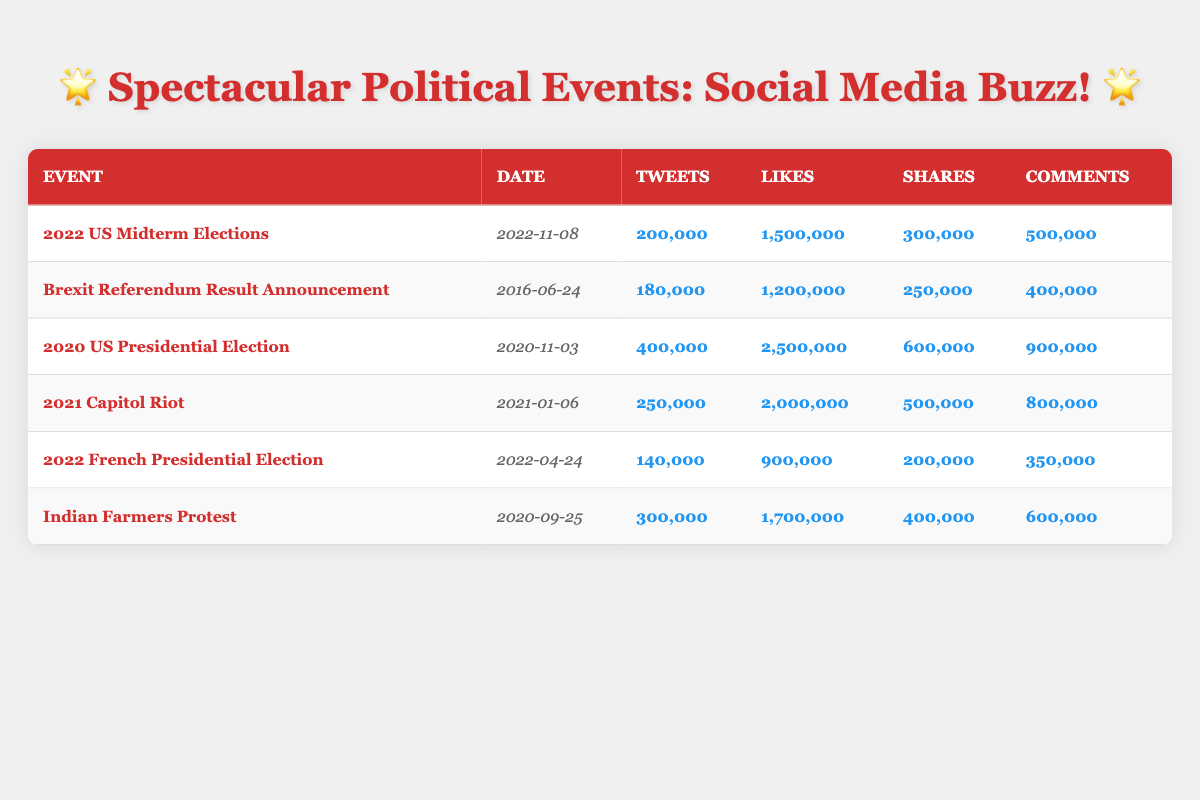What was the highest number of tweets recorded for a single event? The highest number of tweets among the events is found in the row for the 2020 US Presidential Election, which has 400,000 tweets.
Answer: 400,000 How many likes did the 2021 Capitol Riot receive? According to the table, the 2021 Capitol Riot received 2,000,000 likes.
Answer: 2,000,000 What is the total number of shares for the 2022 US Midterm Elections and the 2022 French Presidential Election combined? The shares for the 2022 US Midterm Elections is 300,000 and for the 2022 French Presidential Election is 200,000. Adding these figures: 300,000 + 200,000 equals 500,000.
Answer: 500,000 Did the Indian Farmers Protest receive more total engagement (tweets, likes, shares, comments) than the Brexit Referendum Result Announcement? First, we calculate the total engagement for both events: 
   - Indian Farmers Protest: 300,000 (tweets) + 1,700,000 (likes) + 400,000 (shares) + 600,000 (comments) = 3,000,000. 
   - Brexit Referendum Result Announcement: 180,000 (tweets) + 1,200,000 (likes) + 250,000 (shares) + 400,000 (comments) = 2,030,000. 
   Since 3,000,000 is greater than 2,030,000, the answer is yes.
Answer: Yes What was the average number of comments across all events listed in the table? We first need to sum the comments: 500,000 + 400,000 + 900,000 + 800,000 + 350,000 + 600,000 = 3,550,000. There are 6 events, so we divide 3,550,000 by 6, which equals approximately 591,667.
Answer: 591,667 